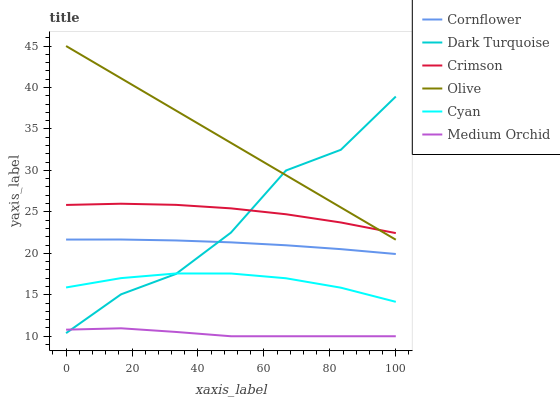Does Medium Orchid have the minimum area under the curve?
Answer yes or no. Yes. Does Olive have the maximum area under the curve?
Answer yes or no. Yes. Does Dark Turquoise have the minimum area under the curve?
Answer yes or no. No. Does Dark Turquoise have the maximum area under the curve?
Answer yes or no. No. Is Olive the smoothest?
Answer yes or no. Yes. Is Dark Turquoise the roughest?
Answer yes or no. Yes. Is Medium Orchid the smoothest?
Answer yes or no. No. Is Medium Orchid the roughest?
Answer yes or no. No. Does Medium Orchid have the lowest value?
Answer yes or no. Yes. Does Dark Turquoise have the lowest value?
Answer yes or no. No. Does Olive have the highest value?
Answer yes or no. Yes. Does Dark Turquoise have the highest value?
Answer yes or no. No. Is Cyan less than Crimson?
Answer yes or no. Yes. Is Olive greater than Cornflower?
Answer yes or no. Yes. Does Crimson intersect Dark Turquoise?
Answer yes or no. Yes. Is Crimson less than Dark Turquoise?
Answer yes or no. No. Is Crimson greater than Dark Turquoise?
Answer yes or no. No. Does Cyan intersect Crimson?
Answer yes or no. No. 